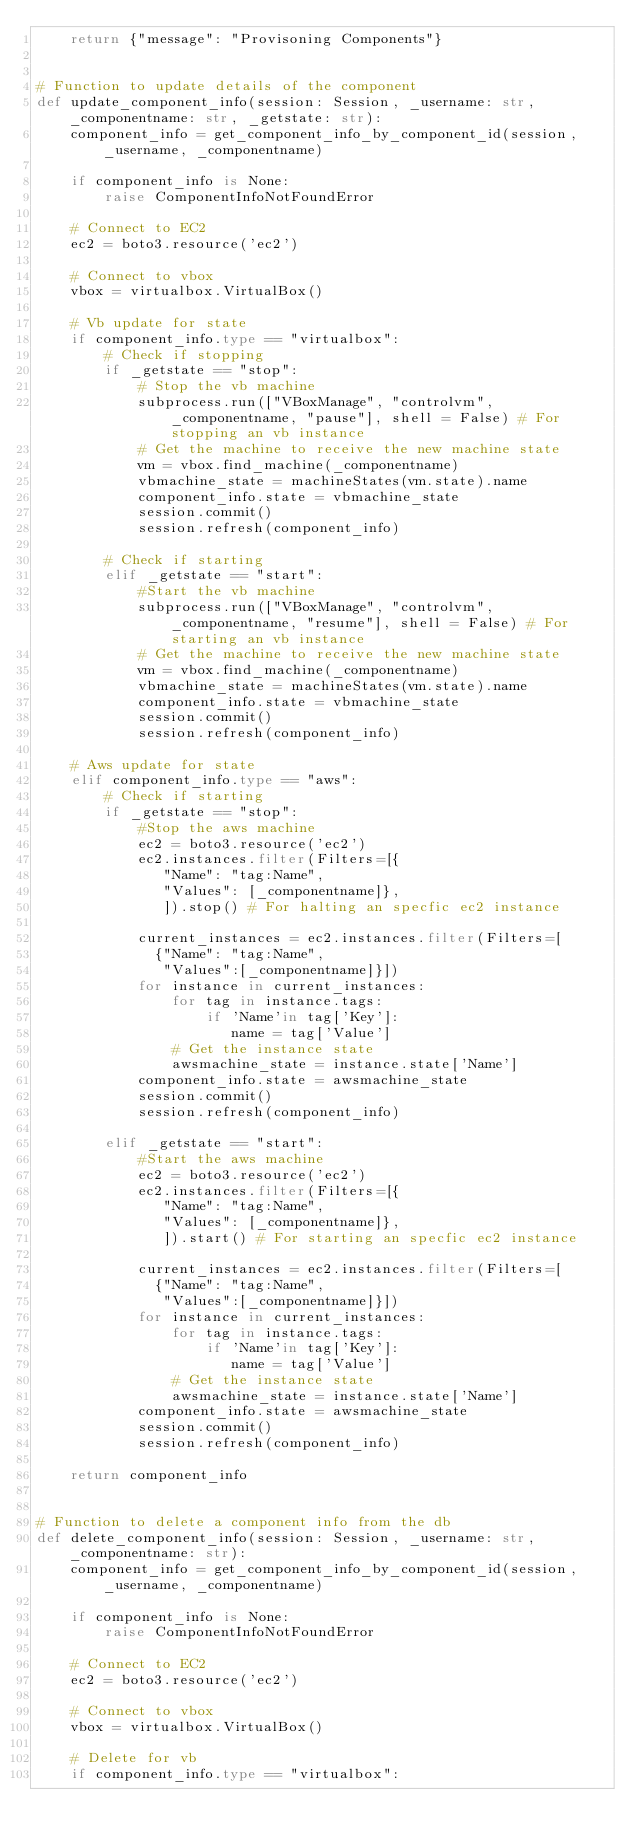<code> <loc_0><loc_0><loc_500><loc_500><_Python_>    return {"message": "Provisoning Components"}


# Function to update details of the component
def update_component_info(session: Session, _username: str, _componentname: str, _getstate: str):
    component_info = get_component_info_by_component_id(session, _username, _componentname)

    if component_info is None:
        raise ComponentInfoNotFoundError
        
    # Connect to EC2
    ec2 = boto3.resource('ec2')
    
    # Connect to vbox
    vbox = virtualbox.VirtualBox()
        
    # Vb update for state 
    if component_info.type == "virtualbox":
        # Check if stopping
        if _getstate == "stop":
            # Stop the vb machine
            subprocess.run(["VBoxManage", "controlvm", _componentname, "pause"], shell = False) # For stopping an vb instance
            # Get the machine to receive the new machine state
            vm = vbox.find_machine(_componentname)
            vbmachine_state = machineStates(vm.state).name
            component_info.state = vbmachine_state
            session.commit()
            session.refresh(component_info)
        
        # Check if starting
        elif _getstate == "start":
            #Start the vb machine
            subprocess.run(["VBoxManage", "controlvm", _componentname, "resume"], shell = False) # For starting an vb instance
            # Get the machine to receive the new machine state
            vm = vbox.find_machine(_componentname)
            vbmachine_state = machineStates(vm.state).name
            component_info.state = vbmachine_state
            session.commit()
            session.refresh(component_info)
           
    # Aws update for state
    elif component_info.type == "aws":
        # Check if starting
        if _getstate == "stop":
            #Stop the aws machine
            ec2 = boto3.resource('ec2')
            ec2.instances.filter(Filters=[{
               "Name": "tag:Name",
               "Values": [_componentname]},
               ]).stop() # For halting an specfic ec2 instance
               
            current_instances = ec2.instances.filter(Filters=[
              {"Name": "tag:Name",
               "Values":[_componentname]}])
            for instance in current_instances:
                for tag in instance.tags:
                    if 'Name'in tag['Key']:
                       name = tag['Value']
                # Get the instance state
                awsmachine_state = instance.state['Name']
            component_info.state = awsmachine_state
            session.commit()
            session.refresh(component_info)
            
        elif _getstate == "start":
            #Start the aws machine
            ec2 = boto3.resource('ec2')
            ec2.instances.filter(Filters=[{
               "Name": "tag:Name",
               "Values": [_componentname]},
               ]).start() # For starting an specfic ec2 instance
               
            current_instances = ec2.instances.filter(Filters=[
              {"Name": "tag:Name",
               "Values":[_componentname]}])
            for instance in current_instances:
                for tag in instance.tags:
                    if 'Name'in tag['Key']:
                       name = tag['Value']
                # Get the instance state
                awsmachine_state = instance.state['Name']
            component_info.state = awsmachine_state
            session.commit()
            session.refresh(component_info)

    return component_info


# Function to delete a component info from the db
def delete_component_info(session: Session, _username: str, _componentname: str):
    component_info = get_component_info_by_component_id(session, _username, _componentname)

    if component_info is None:
        raise ComponentInfoNotFoundError
        
    # Connect to EC2
    ec2 = boto3.resource('ec2')
    
    # Connect to vbox
    vbox = virtualbox.VirtualBox()        
        
    # Delete for vb
    if component_info.type == "virtualbox":</code> 